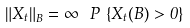<formula> <loc_0><loc_0><loc_500><loc_500>\left \| X _ { t } \right \| _ { B } = \infty \ \, P \, \left \{ X _ { t } ( B ) > 0 \right \}</formula> 